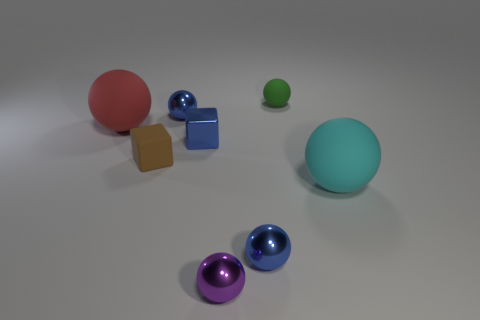Subtract 3 balls. How many balls are left? 3 Subtract all green matte balls. How many balls are left? 5 Subtract all green balls. How many balls are left? 5 Subtract all purple balls. Subtract all blue cubes. How many balls are left? 5 Add 2 shiny balls. How many objects exist? 10 Subtract all blocks. How many objects are left? 6 Add 5 small blue metallic spheres. How many small blue metallic spheres are left? 7 Add 7 red metallic objects. How many red metallic objects exist? 7 Subtract 0 yellow cylinders. How many objects are left? 8 Subtract all gray matte spheres. Subtract all small green balls. How many objects are left? 7 